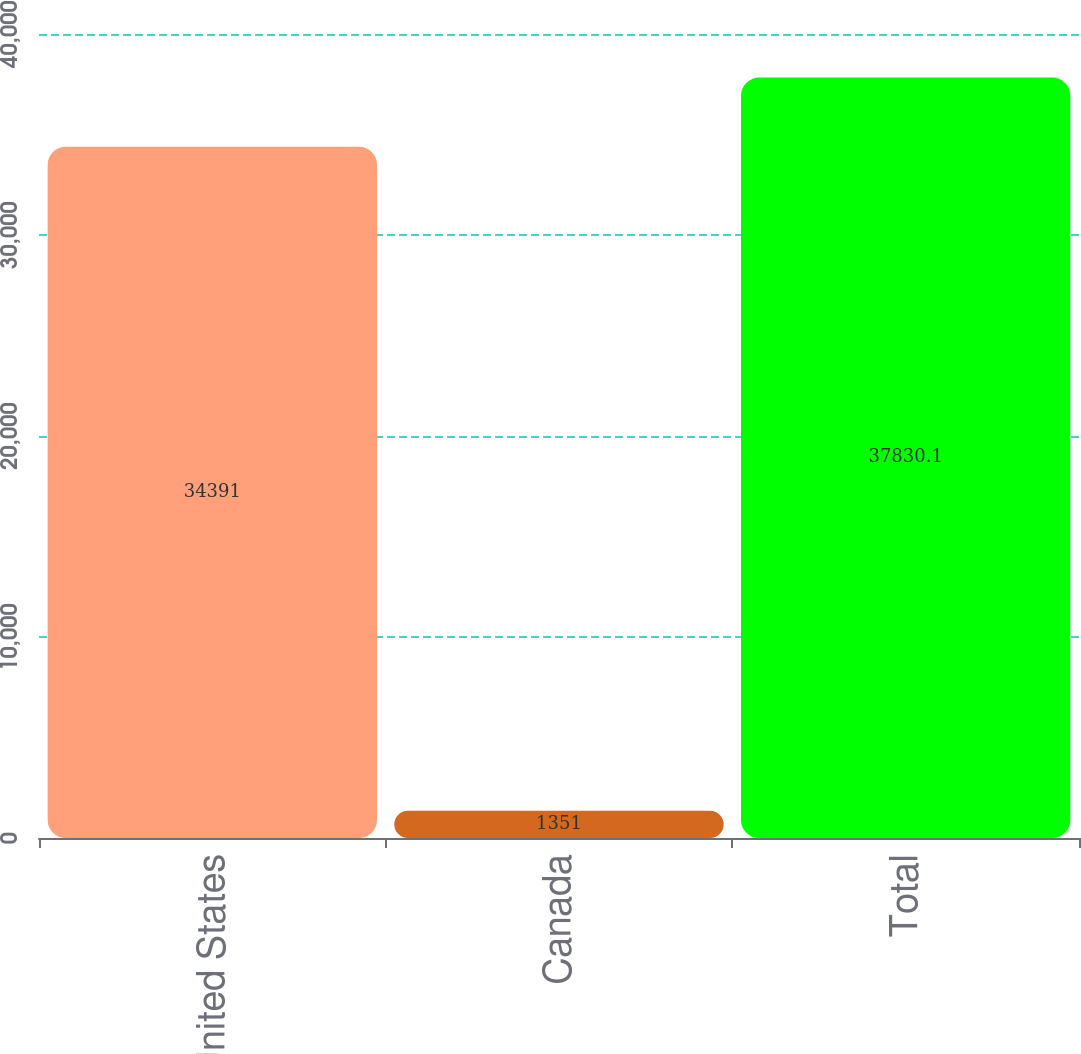<chart> <loc_0><loc_0><loc_500><loc_500><bar_chart><fcel>United States<fcel>Canada<fcel>Total<nl><fcel>34391<fcel>1351<fcel>37830.1<nl></chart> 